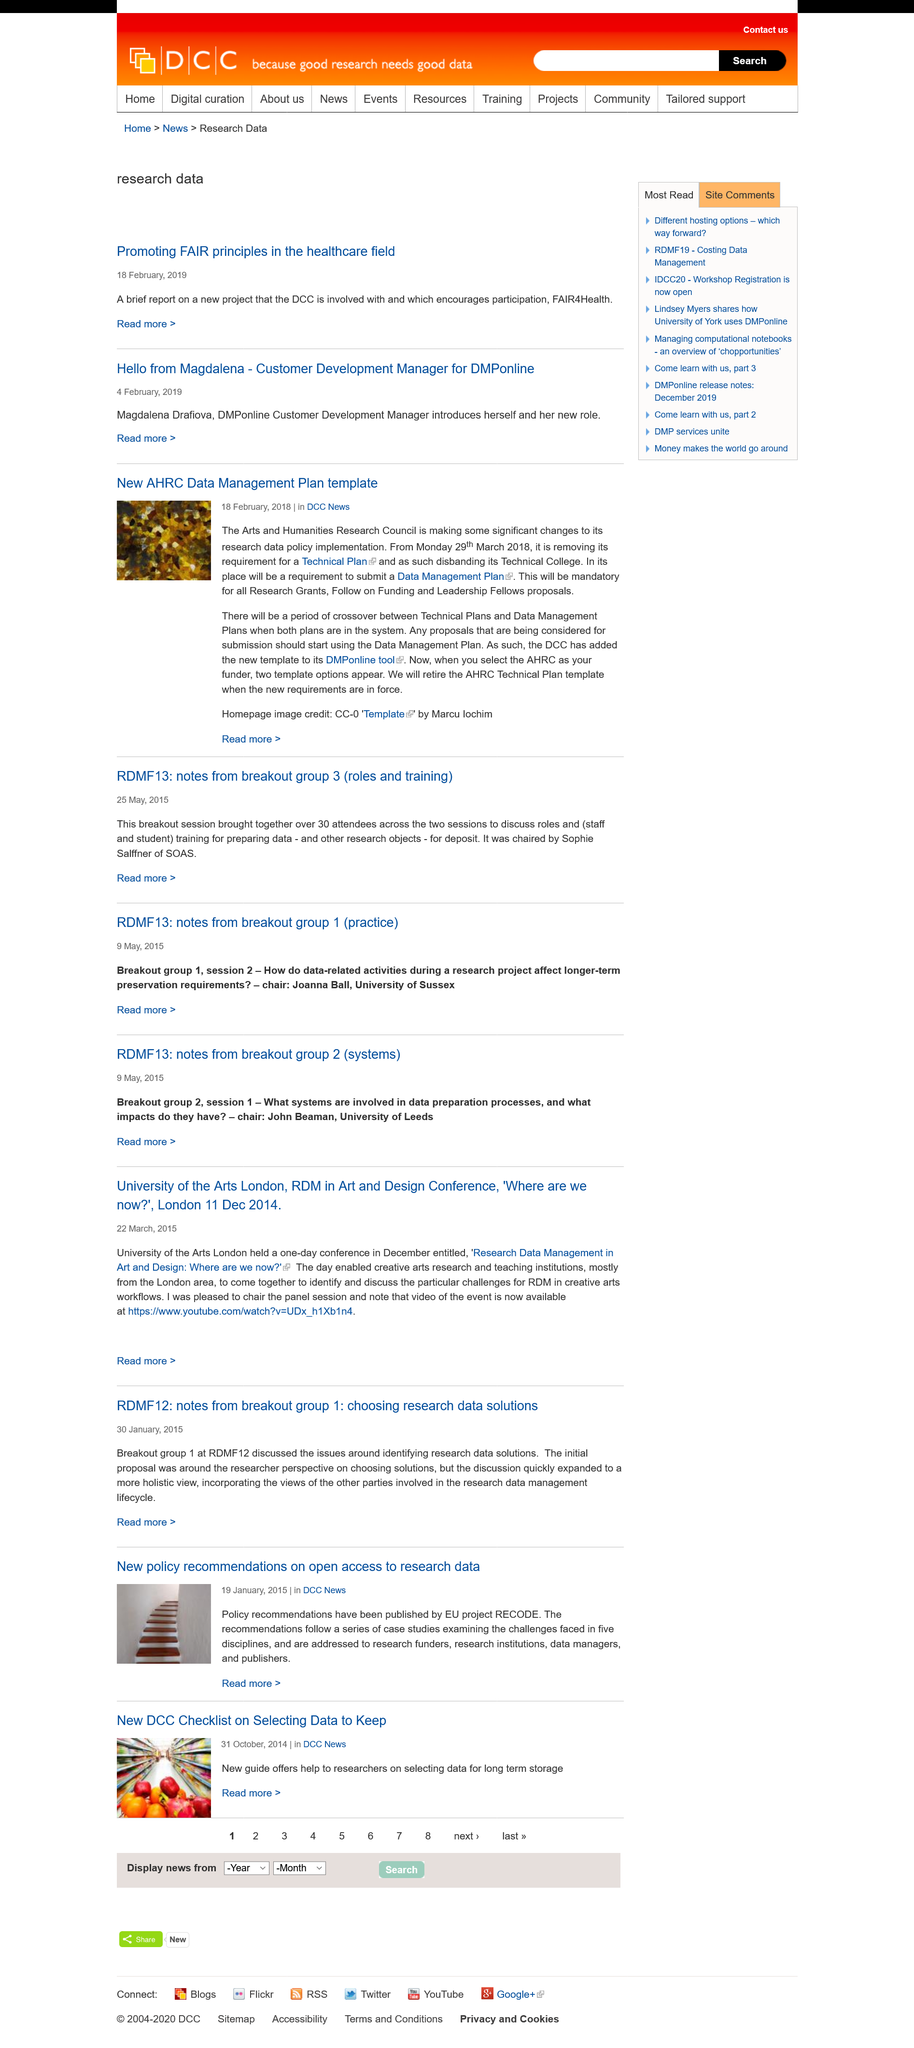Indicate a few pertinent items in this graphic. The Arts and Humanities Research Council, also known as AHRC, is a national organization that supports and funds research in the arts and humanities. On the 18th day of February in the year 2018, this template was published. The image is created by Marcu Lochim. 